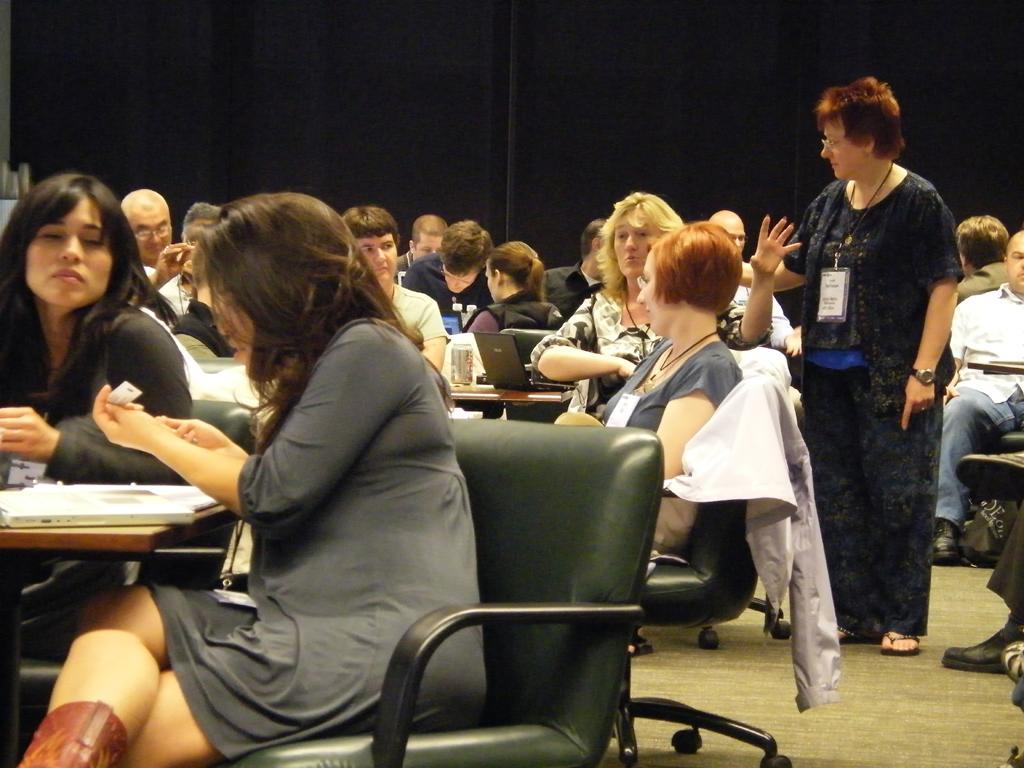Please provide a concise description of this image. In this picture there are persons sitting and there is a person standing and there are tables, on the tables there are objects. In the background there is a curtain which is black in colour. 